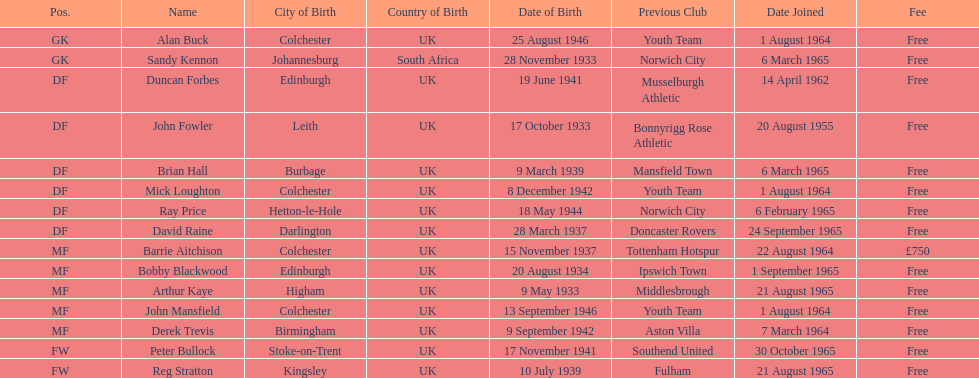What is the date of the lst player that joined? 20 August 1955. 